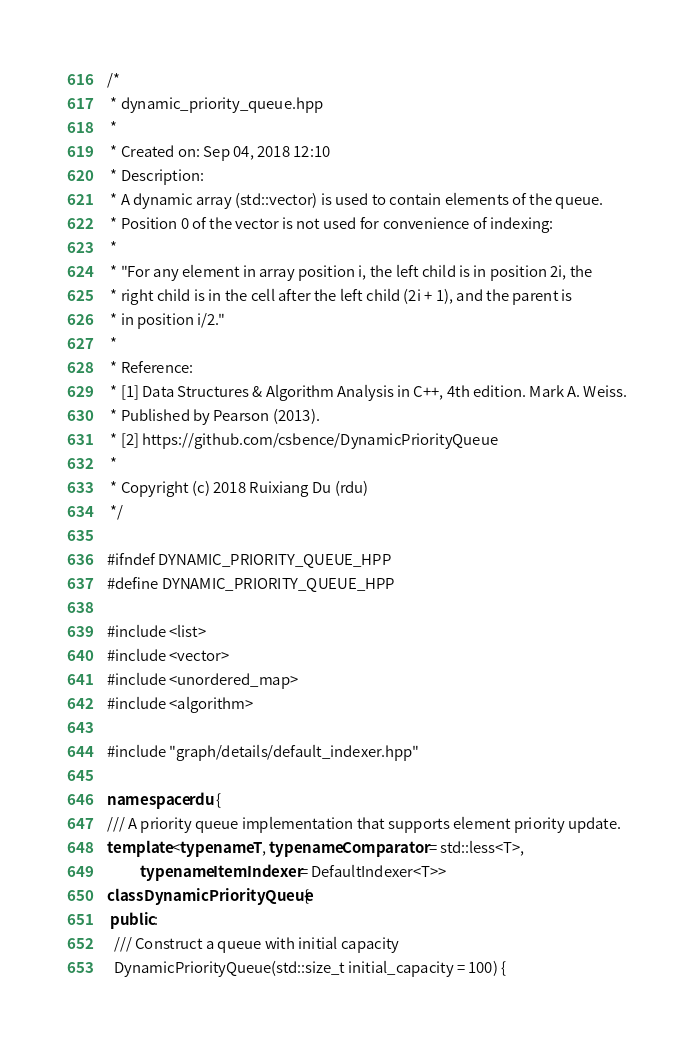Convert code to text. <code><loc_0><loc_0><loc_500><loc_500><_C++_>/*
 * dynamic_priority_queue.hpp
 *
 * Created on: Sep 04, 2018 12:10
 * Description:
 * A dynamic array (std::vector) is used to contain elements of the queue.
 * Position 0 of the vector is not used for convenience of indexing:
 *
 * "For any element in array position i, the left child is in position 2i, the
 * right child is in the cell after the left child (2i + 1), and the parent is
 * in position i/2."
 *
 * Reference:
 * [1] Data Structures & Algorithm Analysis in C++, 4th edition. Mark A. Weiss.
 * Published by Pearson (2013).
 * [2] https://github.com/csbence/DynamicPriorityQueue
 *
 * Copyright (c) 2018 Ruixiang Du (rdu)
 */

#ifndef DYNAMIC_PRIORITY_QUEUE_HPP
#define DYNAMIC_PRIORITY_QUEUE_HPP

#include <list>
#include <vector>
#include <unordered_map>
#include <algorithm>

#include "graph/details/default_indexer.hpp"

namespace rdu {
/// A priority queue implementation that supports element priority update.
template <typename T, typename Comparator = std::less<T>,
          typename ItemIndexer = DefaultIndexer<T>>
class DynamicPriorityQueue {
 public:
  /// Construct a queue with initial capacity
  DynamicPriorityQueue(std::size_t initial_capacity = 100) {</code> 